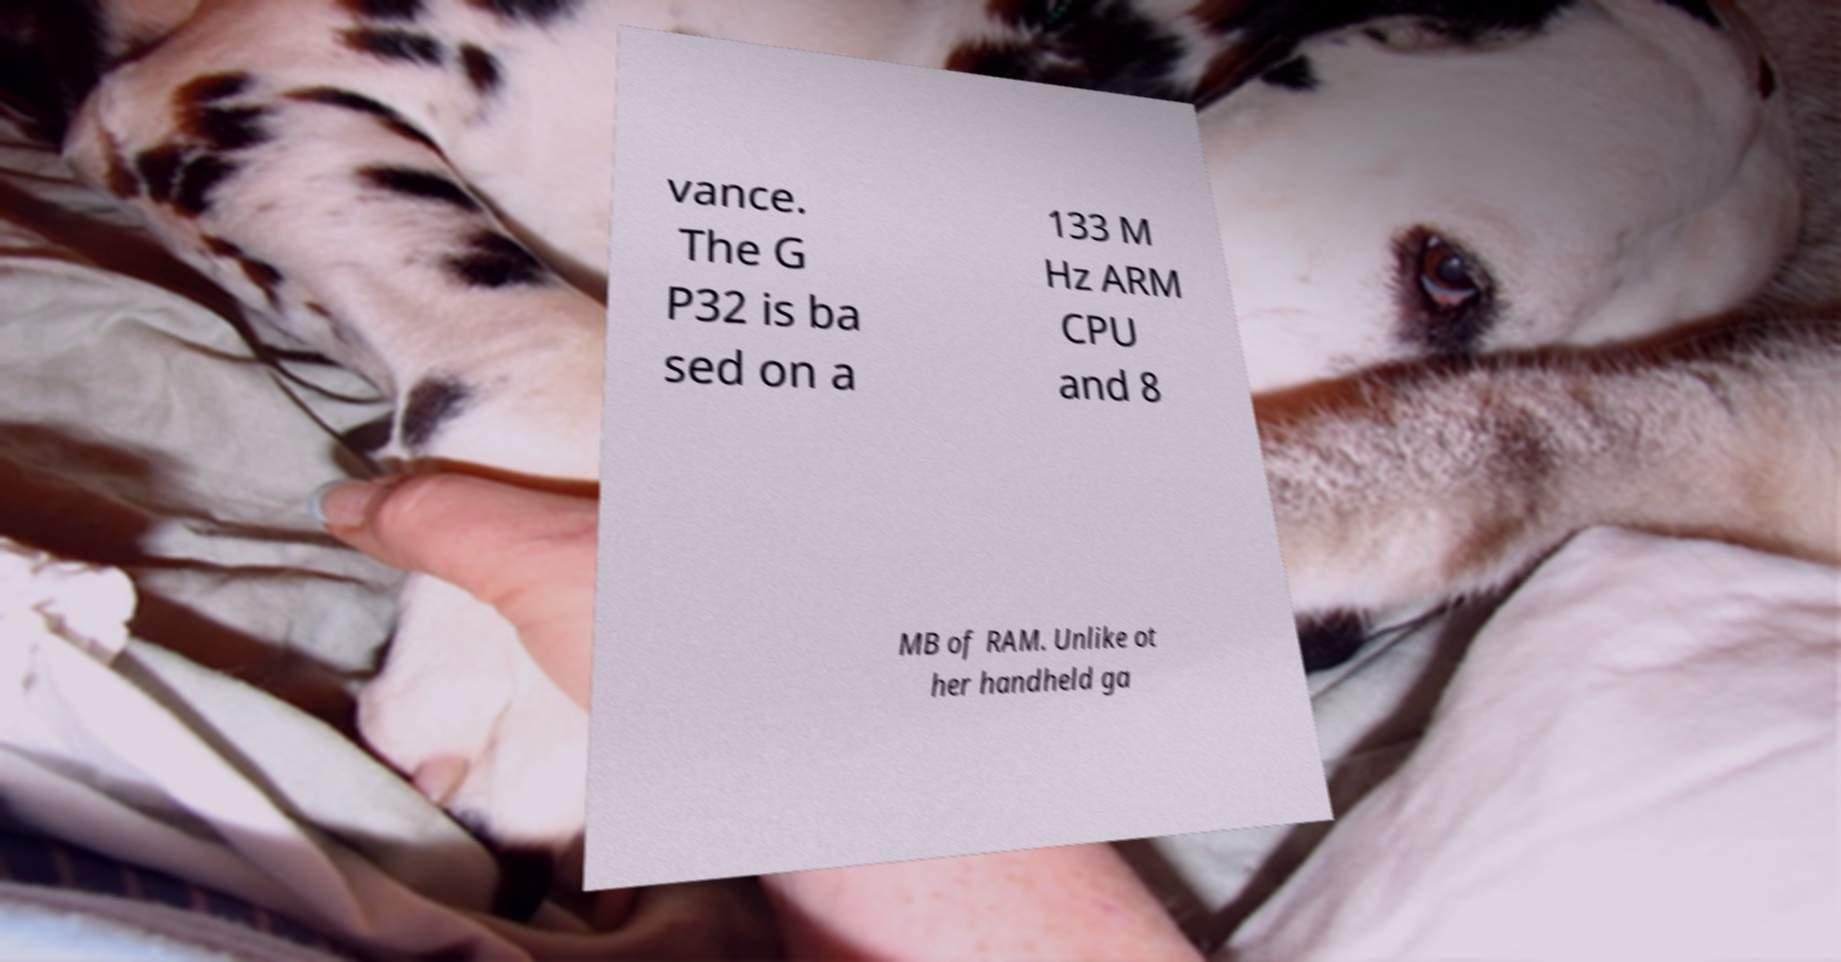Can you read and provide the text displayed in the image?This photo seems to have some interesting text. Can you extract and type it out for me? vance. The G P32 is ba sed on a 133 M Hz ARM CPU and 8 MB of RAM. Unlike ot her handheld ga 